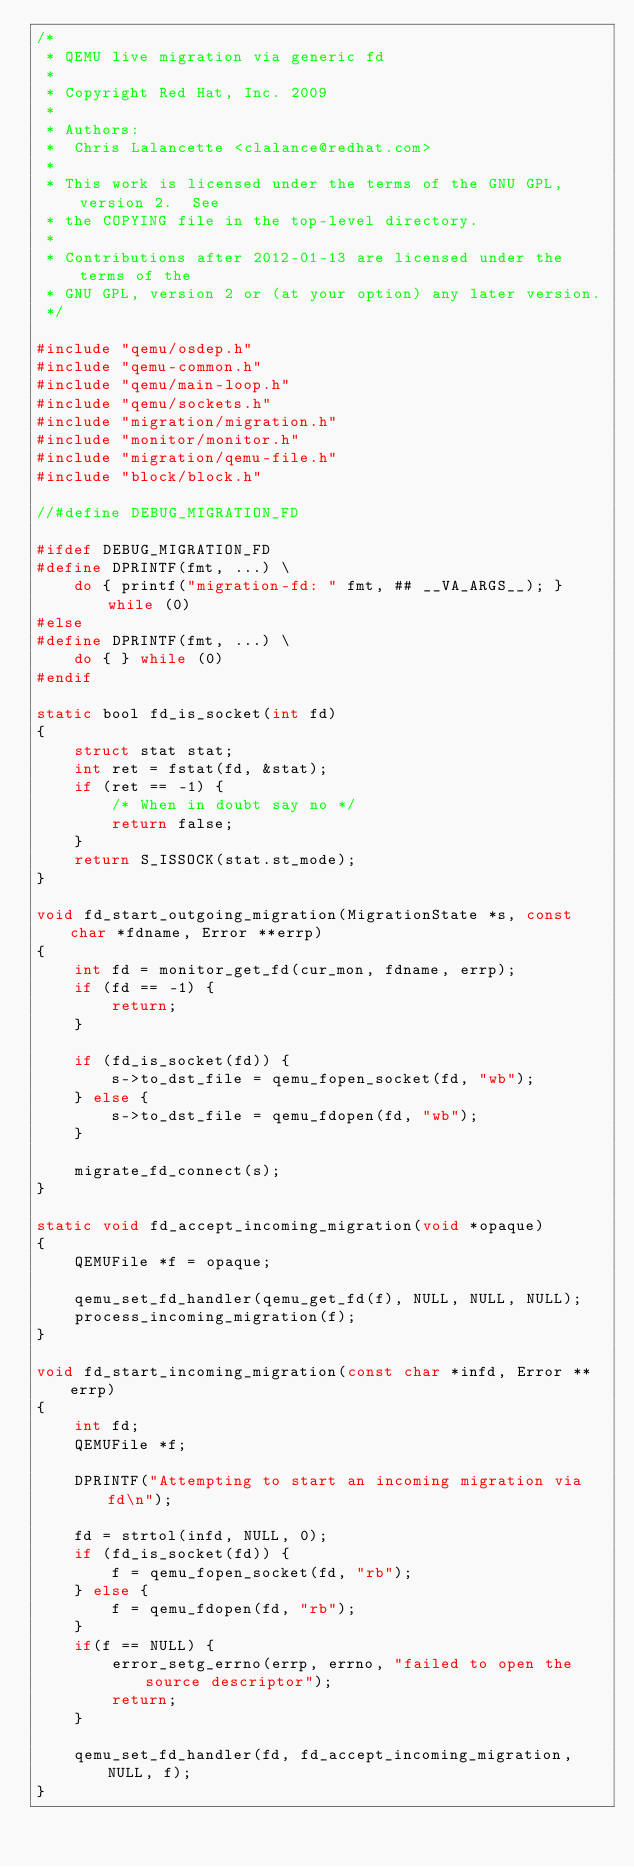<code> <loc_0><loc_0><loc_500><loc_500><_C_>/*
 * QEMU live migration via generic fd
 *
 * Copyright Red Hat, Inc. 2009
 *
 * Authors:
 *  Chris Lalancette <clalance@redhat.com>
 *
 * This work is licensed under the terms of the GNU GPL, version 2.  See
 * the COPYING file in the top-level directory.
 *
 * Contributions after 2012-01-13 are licensed under the terms of the
 * GNU GPL, version 2 or (at your option) any later version.
 */

#include "qemu/osdep.h"
#include "qemu-common.h"
#include "qemu/main-loop.h"
#include "qemu/sockets.h"
#include "migration/migration.h"
#include "monitor/monitor.h"
#include "migration/qemu-file.h"
#include "block/block.h"

//#define DEBUG_MIGRATION_FD

#ifdef DEBUG_MIGRATION_FD
#define DPRINTF(fmt, ...) \
    do { printf("migration-fd: " fmt, ## __VA_ARGS__); } while (0)
#else
#define DPRINTF(fmt, ...) \
    do { } while (0)
#endif

static bool fd_is_socket(int fd)
{
    struct stat stat;
    int ret = fstat(fd, &stat);
    if (ret == -1) {
        /* When in doubt say no */
        return false;
    }
    return S_ISSOCK(stat.st_mode);
}

void fd_start_outgoing_migration(MigrationState *s, const char *fdname, Error **errp)
{
    int fd = monitor_get_fd(cur_mon, fdname, errp);
    if (fd == -1) {
        return;
    }

    if (fd_is_socket(fd)) {
        s->to_dst_file = qemu_fopen_socket(fd, "wb");
    } else {
        s->to_dst_file = qemu_fdopen(fd, "wb");
    }

    migrate_fd_connect(s);
}

static void fd_accept_incoming_migration(void *opaque)
{
    QEMUFile *f = opaque;

    qemu_set_fd_handler(qemu_get_fd(f), NULL, NULL, NULL);
    process_incoming_migration(f);
}

void fd_start_incoming_migration(const char *infd, Error **errp)
{
    int fd;
    QEMUFile *f;

    DPRINTF("Attempting to start an incoming migration via fd\n");

    fd = strtol(infd, NULL, 0);
    if (fd_is_socket(fd)) {
        f = qemu_fopen_socket(fd, "rb");
    } else {
        f = qemu_fdopen(fd, "rb");
    }
    if(f == NULL) {
        error_setg_errno(errp, errno, "failed to open the source descriptor");
        return;
    }

    qemu_set_fd_handler(fd, fd_accept_incoming_migration, NULL, f);
}
</code> 